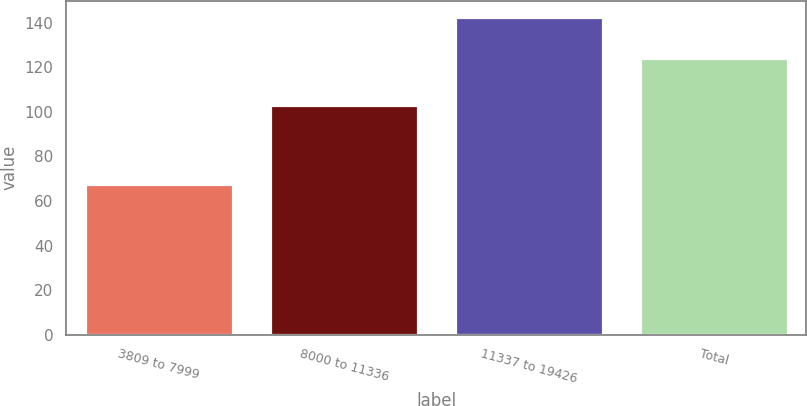Convert chart to OTSL. <chart><loc_0><loc_0><loc_500><loc_500><bar_chart><fcel>3809 to 7999<fcel>8000 to 11336<fcel>11337 to 19426<fcel>Total<nl><fcel>67.58<fcel>103.01<fcel>142.69<fcel>124.41<nl></chart> 